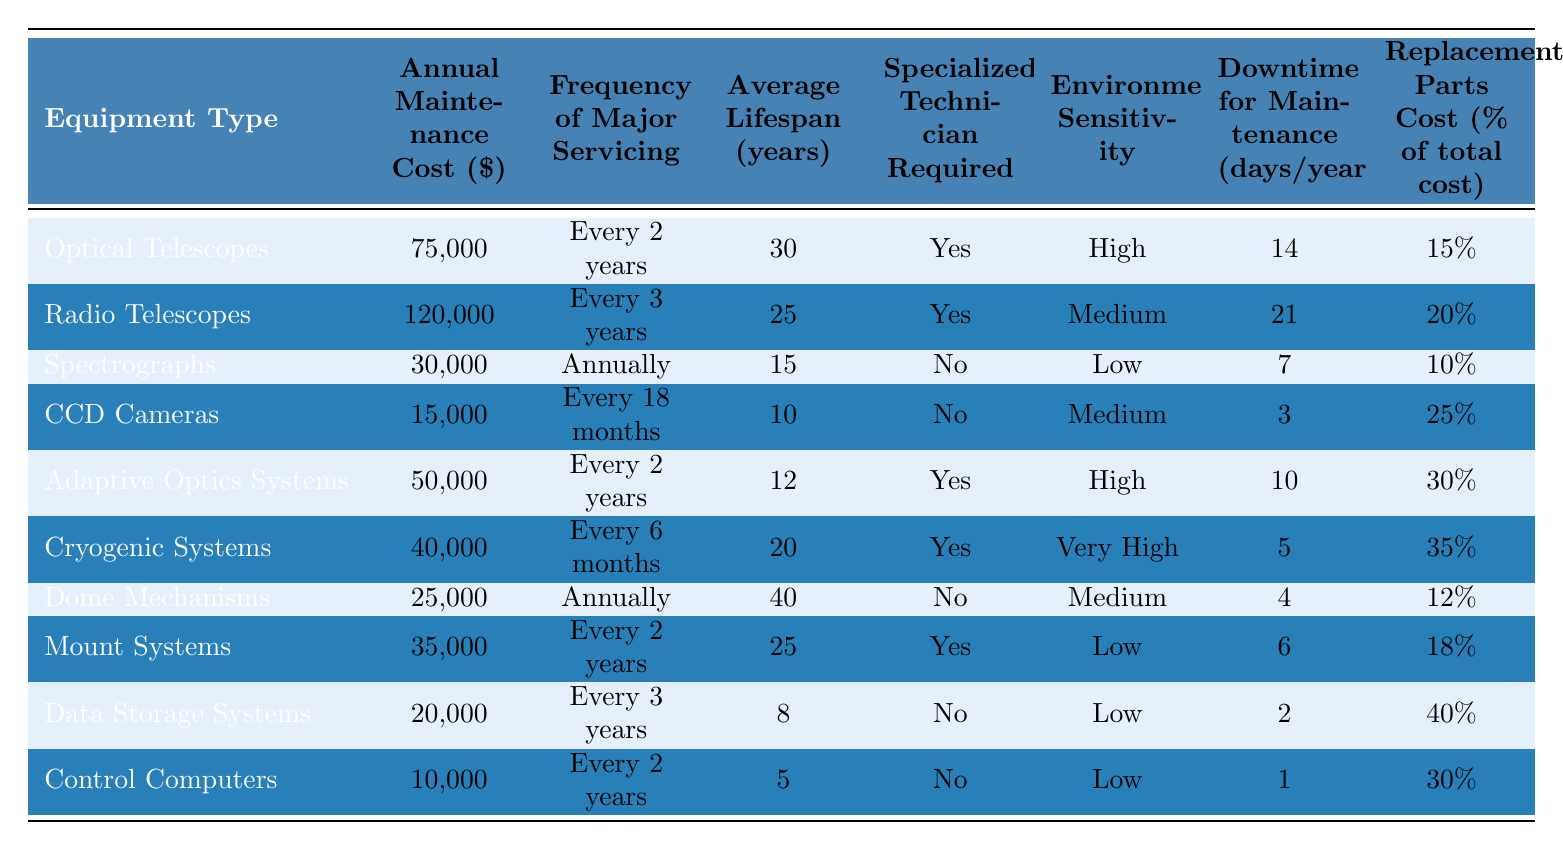What is the most expensive equipment type in terms of annual maintenance cost? By examining the "Annual Maintenance Cost ($)" column, we can see that "Radio Telescopes" have the highest cost at $120,000.
Answer: Radio Telescopes How much does maintenance for CCD Cameras cost annually? The table lists the annual maintenance cost for "CCD Cameras," which is $15,000.
Answer: $15,000 Which equipment requires a specialized technician for maintenance? In the "Specialized Technician Required" column, we identify that Optical Telescopes, Radio Telescopes, Adaptive Optics Systems, and Cryogenic Systems require specialized technicians.
Answer: Yes, 4 types What is the average downtime for maintenance across all equipment types? The downtime values are 14, 21, 7, 3, 10, 5, 4, 6, 2, and 1 days. Summing these gives 69 days, and dividing by 10 (the number of types) yields an average of 6.9 days.
Answer: 6.9 days Which equipment type has the longest average lifespan? From the "Average Lifespan (years)" column, we see "Dome Mechanisms" has the longest lifespan at 40 years.
Answer: Dome Mechanisms How many types of equipment have a frequency of major servicing that occurs annually? By checking the "Frequency of Major Servicing" column, we find that "Spectrographs" and "Dome Mechanisms" are serviced annually, giving a total of 2.
Answer: 2 types What percentage of the replacement parts cost does "Data Storage Systems" represent? The table shows that the replacement parts cost for "Data Storage Systems" is 40% of the total maintenance cost.
Answer: 40% How does the downtime for maintenance compare between Optical Telescopes and Control Computers? "Optical Telescopes" have 14 days of downtime while "Control Computers" have 1 day. The difference is 14 - 1 = 13 days.
Answer: 13 days What is the total annual maintenance cost for equipment requiring specialized technicians? The relevant equipment types are Optical Telescopes, Radio Telescopes, Adaptive Optics Systems, and Cryogenic Systems with costs of $75,000, $120,000, $50,000, and $40,000 respectively. Summing these gives $285,000.
Answer: $285,000 Is there any equipment type that has a low environmental sensitivity and requires a specialized technician? By analyzing both the "Environmental Sensitivity" and "Specialized Technician Required" columns, we find that none of the low sensitivity equipment types require specialized technicians.
Answer: No 